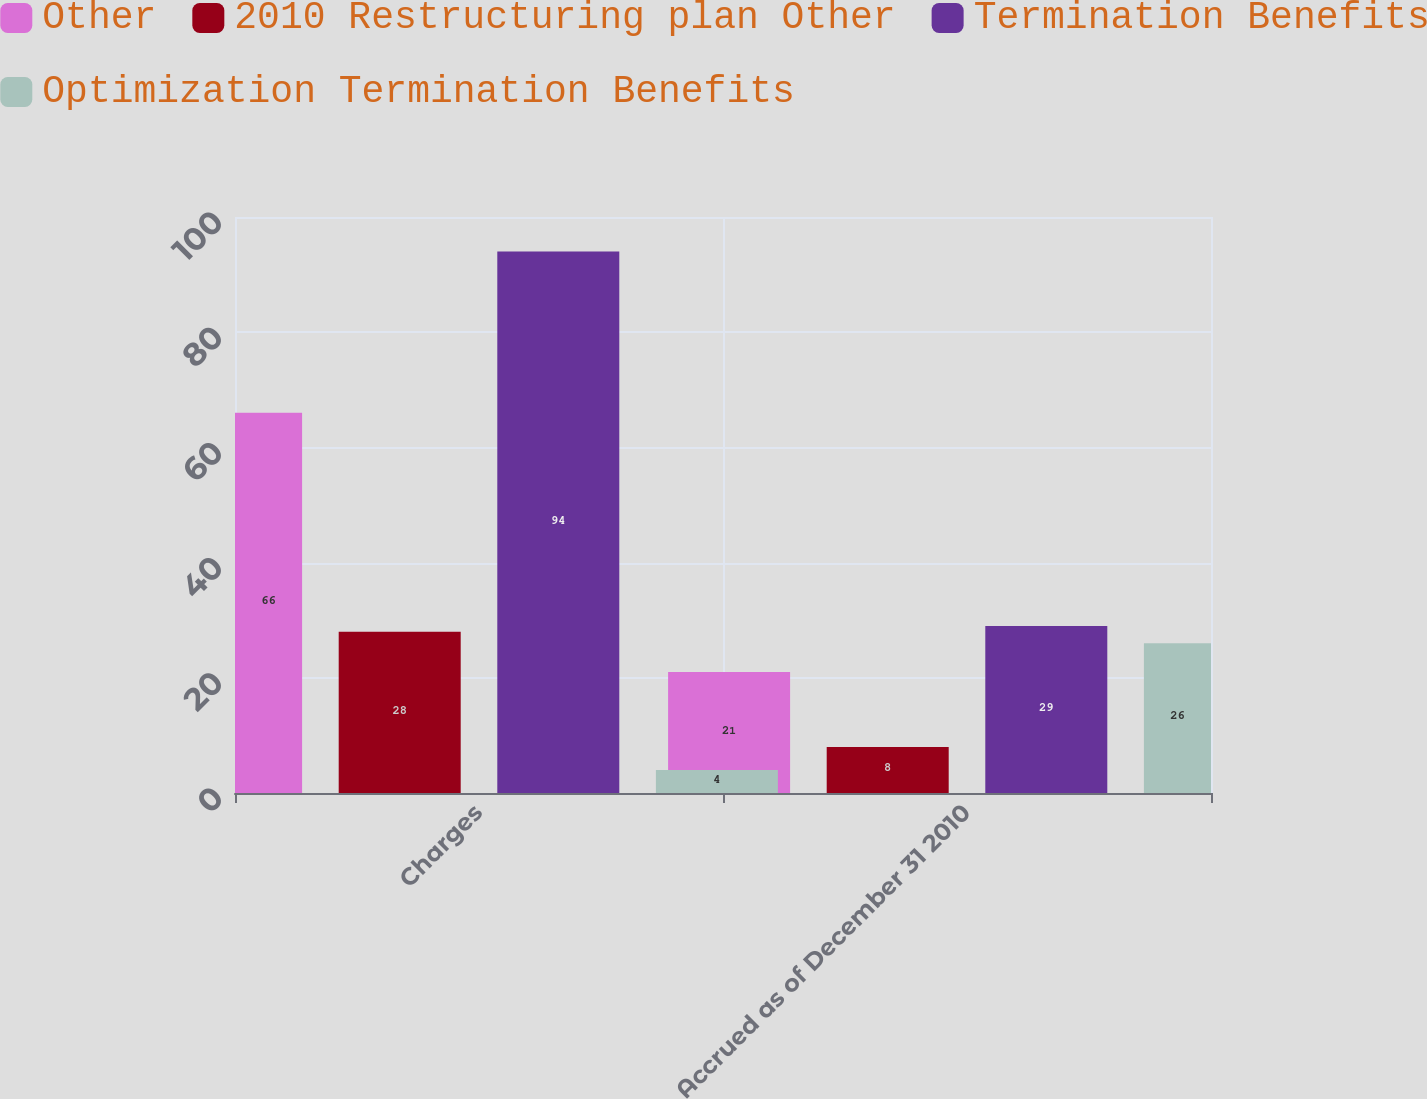Convert chart. <chart><loc_0><loc_0><loc_500><loc_500><stacked_bar_chart><ecel><fcel>Charges<fcel>Accrued as of December 31 2010<nl><fcel>Other<fcel>66<fcel>21<nl><fcel>2010 Restructuring plan Other<fcel>28<fcel>8<nl><fcel>Termination Benefits<fcel>94<fcel>29<nl><fcel>Optimization Termination Benefits<fcel>4<fcel>26<nl></chart> 